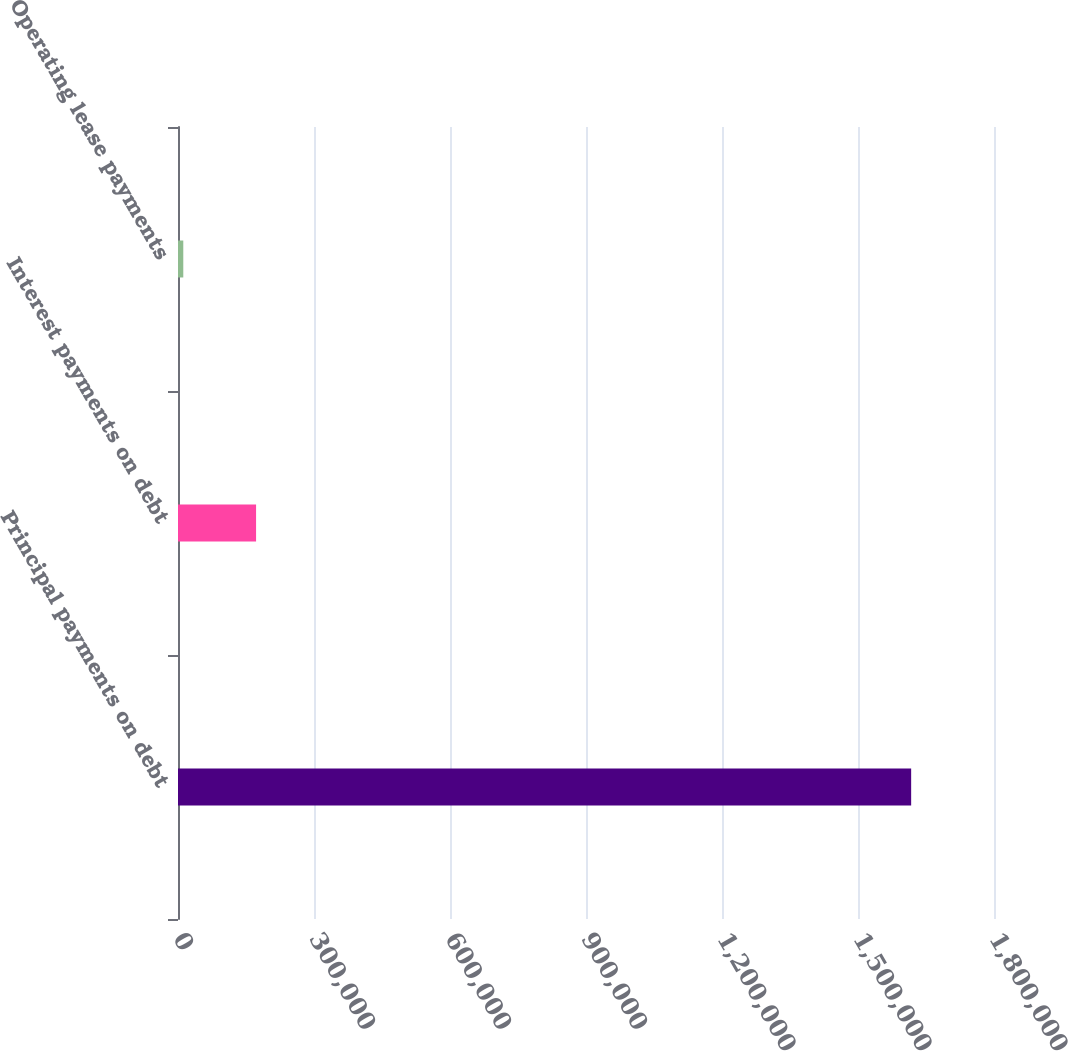<chart> <loc_0><loc_0><loc_500><loc_500><bar_chart><fcel>Principal payments on debt<fcel>Interest payments on debt<fcel>Operating lease payments<nl><fcel>1.61726e+06<fcel>172216<fcel>11655<nl></chart> 